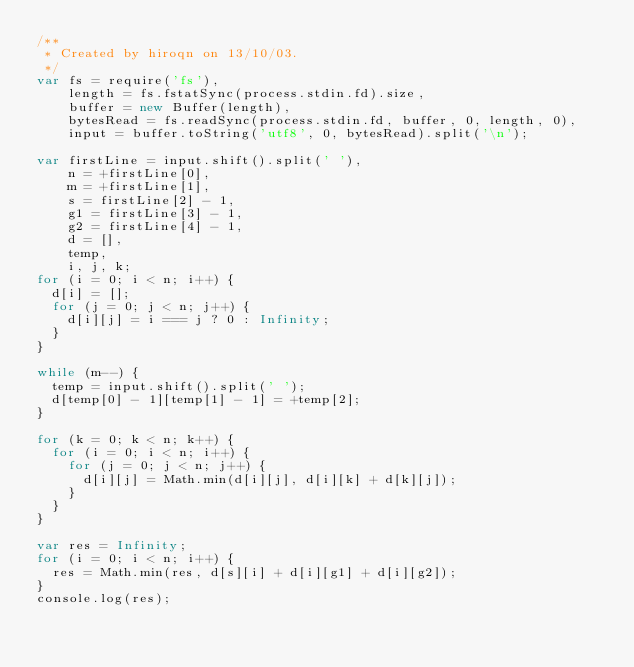<code> <loc_0><loc_0><loc_500><loc_500><_JavaScript_>/**
 * Created by hiroqn on 13/10/03.
 */
var fs = require('fs'),
    length = fs.fstatSync(process.stdin.fd).size,
    buffer = new Buffer(length),
    bytesRead = fs.readSync(process.stdin.fd, buffer, 0, length, 0),
    input = buffer.toString('utf8', 0, bytesRead).split('\n');

var firstLine = input.shift().split(' '),
    n = +firstLine[0],
    m = +firstLine[1],
    s = firstLine[2] - 1,
    g1 = firstLine[3] - 1,
    g2 = firstLine[4] - 1,
    d = [],
    temp,
    i, j, k;
for (i = 0; i < n; i++) {
  d[i] = [];
  for (j = 0; j < n; j++) {
    d[i][j] = i === j ? 0 : Infinity;
  }
}

while (m--) {
  temp = input.shift().split(' ');
  d[temp[0] - 1][temp[1] - 1] = +temp[2];
}

for (k = 0; k < n; k++) {
  for (i = 0; i < n; i++) {
    for (j = 0; j < n; j++) {
      d[i][j] = Math.min(d[i][j], d[i][k] + d[k][j]);
    }
  }
}

var res = Infinity;
for (i = 0; i < n; i++) {
  res = Math.min(res, d[s][i] + d[i][g1] + d[i][g2]);
}
console.log(res);</code> 